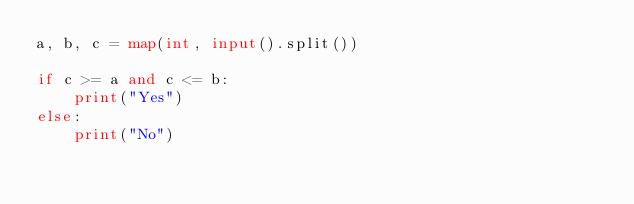Convert code to text. <code><loc_0><loc_0><loc_500><loc_500><_Python_>a, b, c = map(int, input().split())

if c >= a and c <= b:
    print("Yes")
else:
    print("No")
</code> 